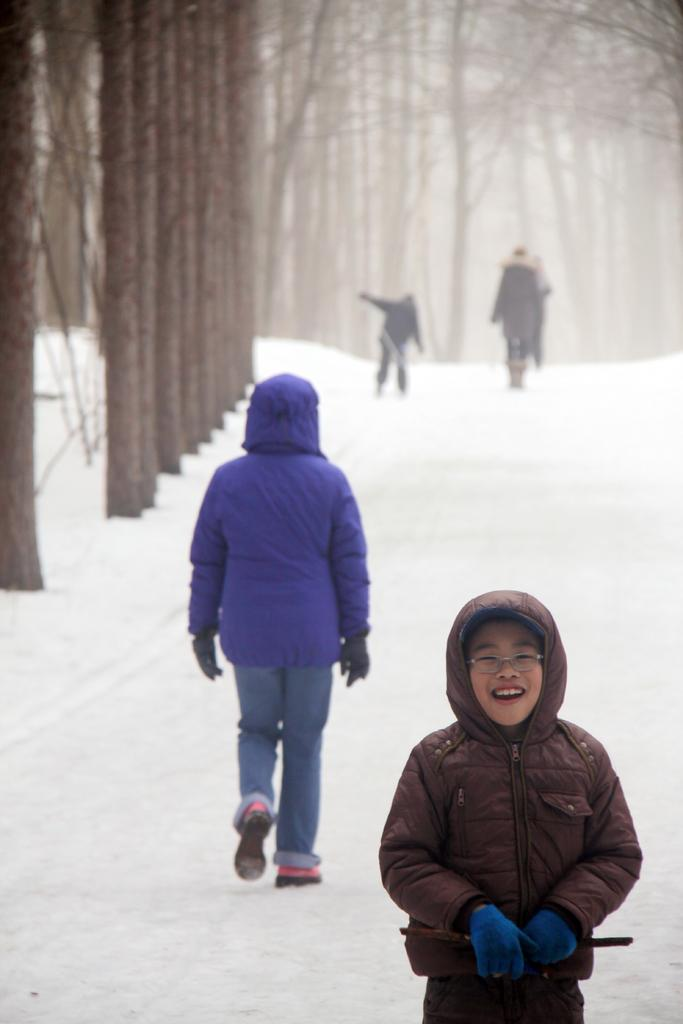What is happening in the foreground of the image? There is a person standing in the foreground of the image, and they are laughing. What can be seen in the background of the image? There is a group of people walking in the background of the image, and there are trees as well. What is the weather like in the image? The presence of snow visible at the bottom of the image suggests that it is snowing or that there has been recent snowfall. What type of toys can be seen on the farm in the image? There is no farm or toys present in the image; it features a person laughing in the foreground and a group of people walking in the background, with snow visible at the bottom. 